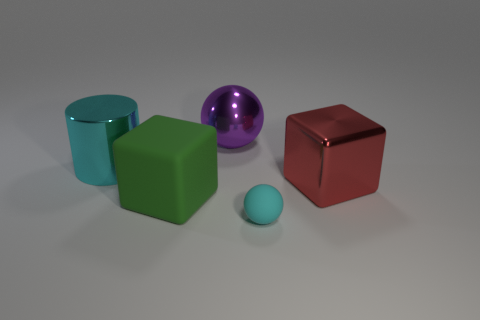Add 2 large brown matte balls. How many objects exist? 7 Subtract all cylinders. How many objects are left? 4 Add 5 tiny green metallic balls. How many tiny green metallic balls exist? 5 Subtract 0 brown cylinders. How many objects are left? 5 Subtract all purple cylinders. Subtract all large purple things. How many objects are left? 4 Add 4 big metal things. How many big metal things are left? 7 